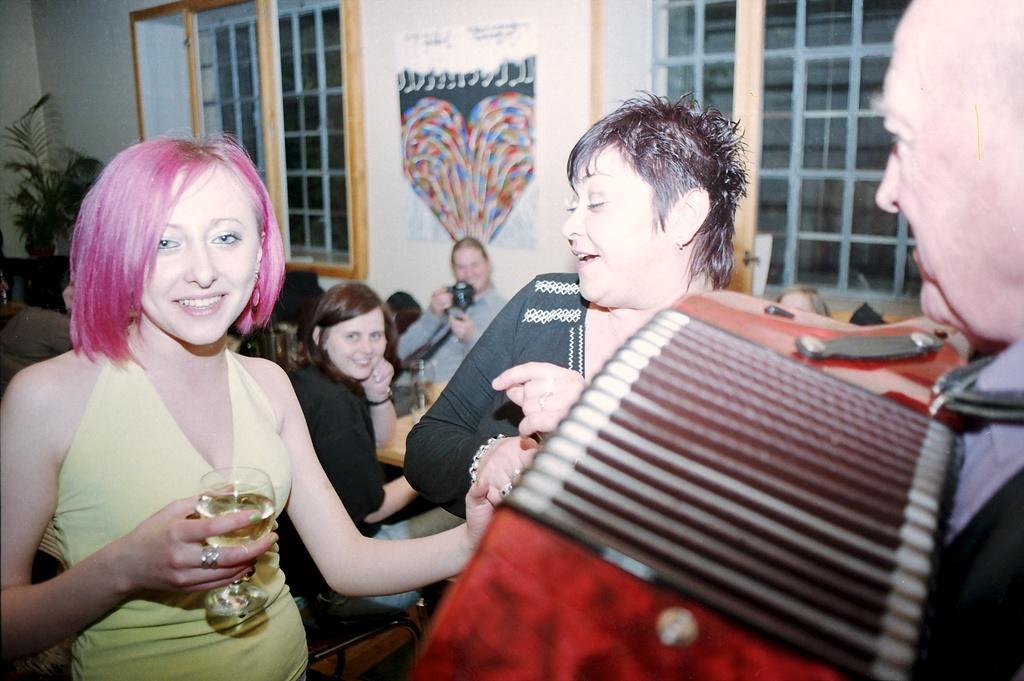Could you give a brief overview of what you see in this image? In this image we can see some people standing. In that a woman is holding a glass and a man is holding the musical instrument. On the backside we can see some people sitting beside a table containing a glass on it. In that a man is holding a device. We can also see a poster on a wall, a plant in a pot and some windows with the metal grill. 